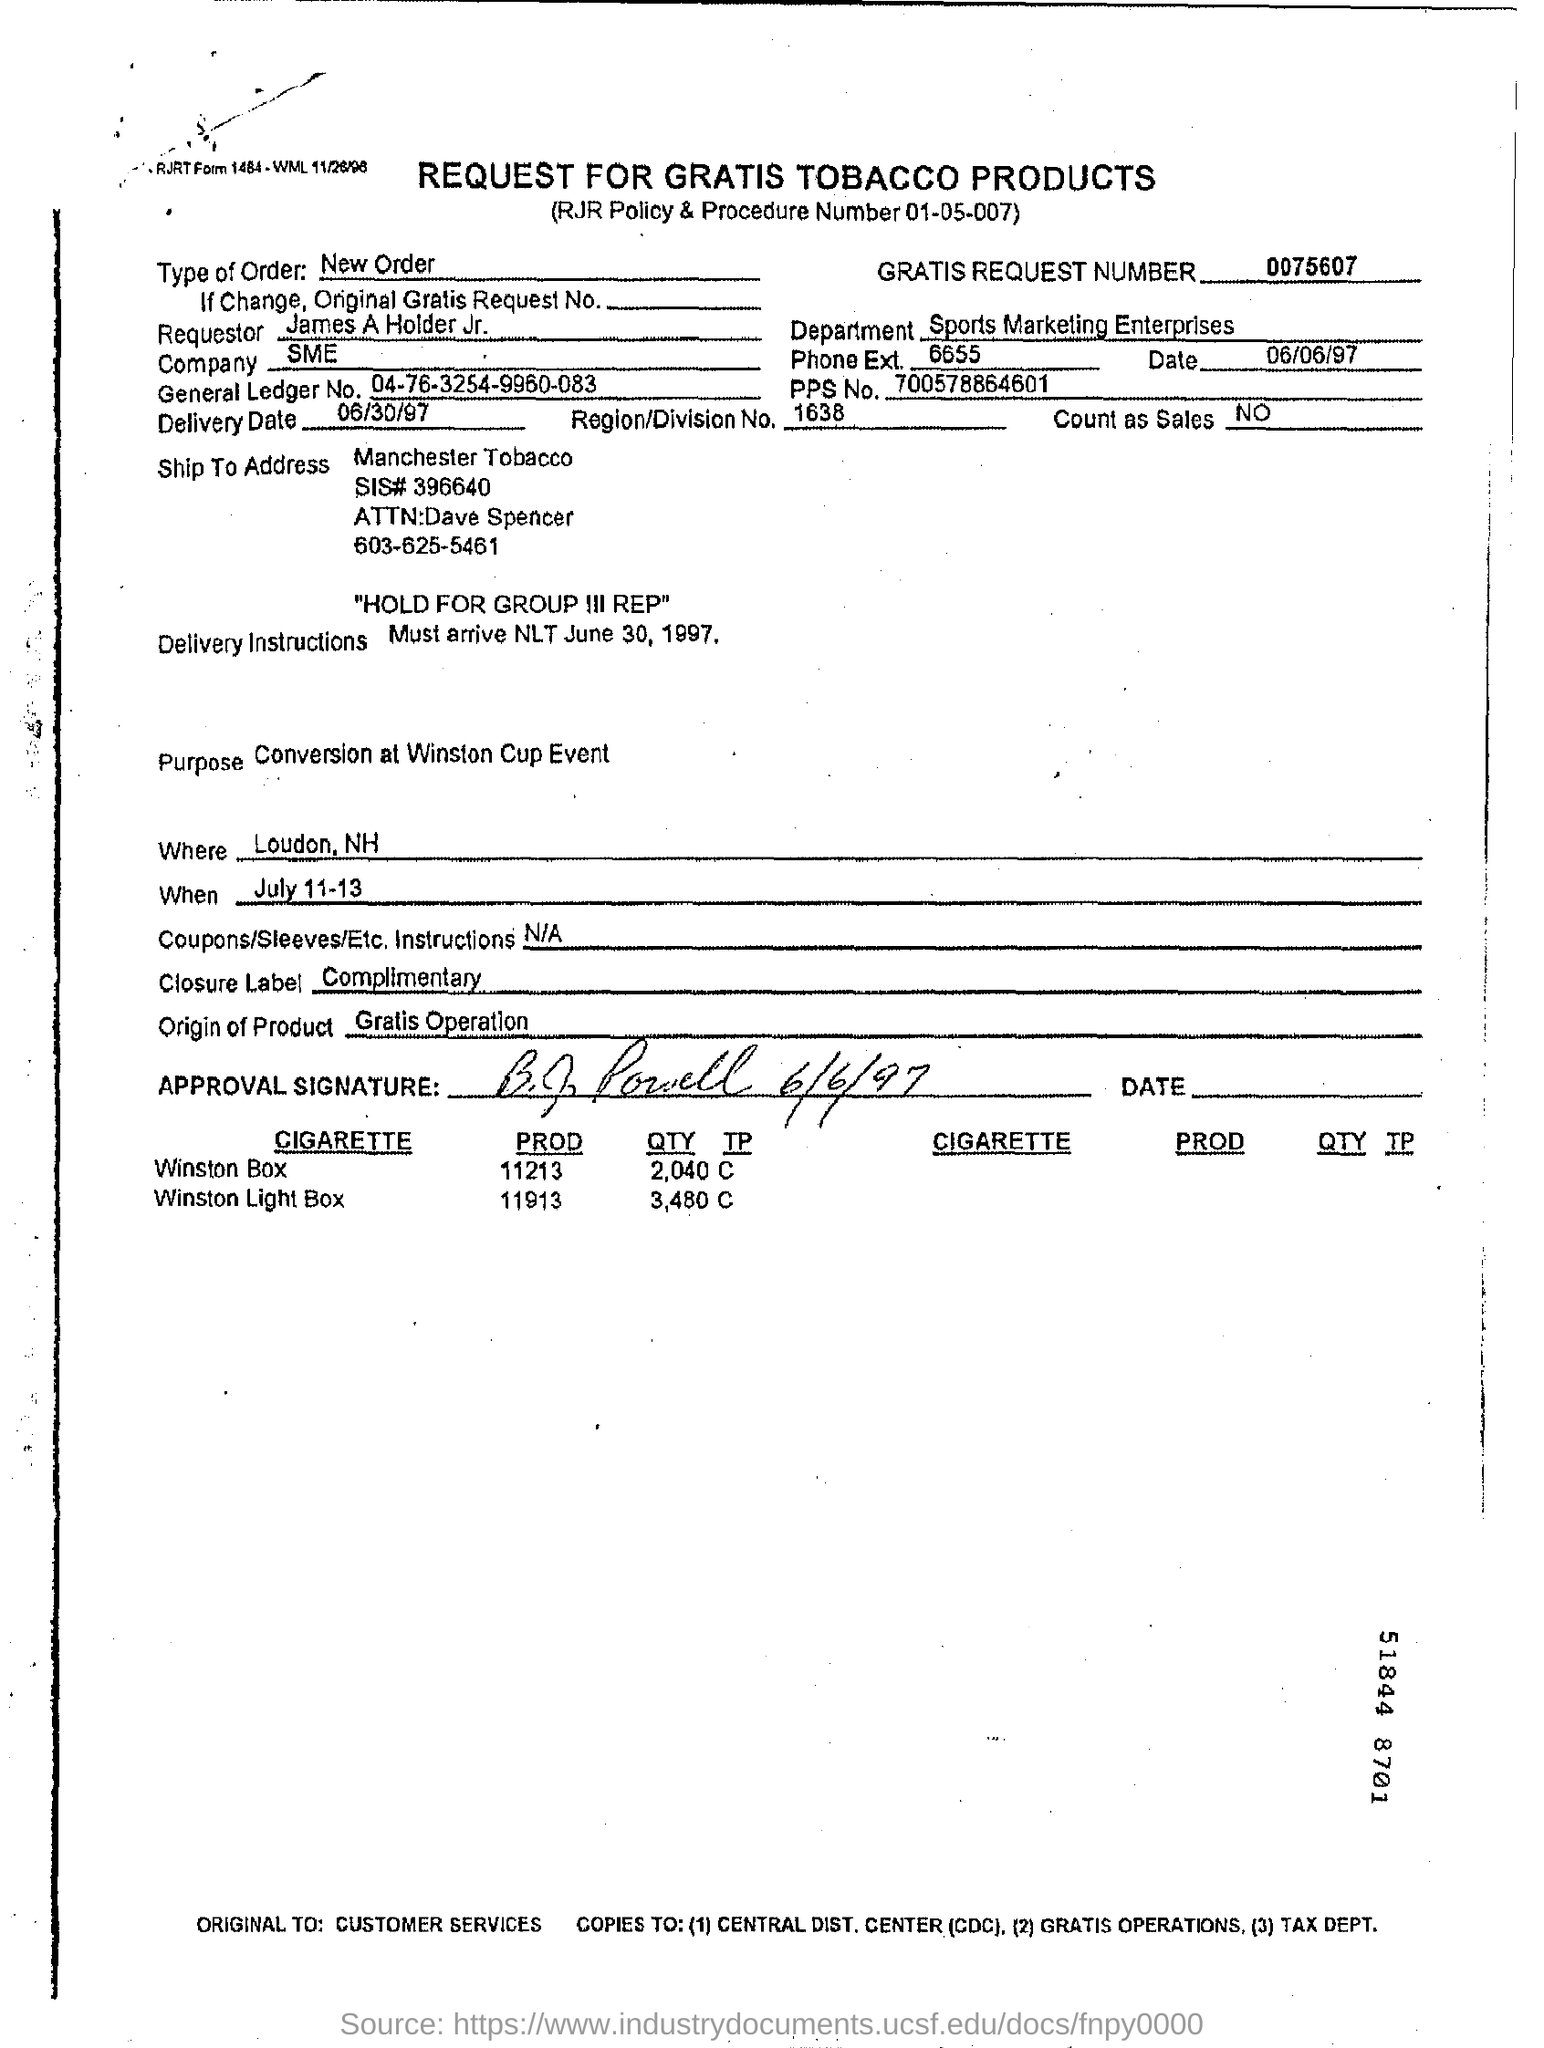Who is the Requestor?
Keep it short and to the point. James A Holder Jr. Which is the company?
Provide a short and direct response. SME. What is the Gratis Request Number?
Your answer should be very brief. 0075607. What is the Delivery Date?
Your answer should be compact. 06/30/97. What is the Region/Division No. ?
Your answer should be compact. 1638. What is the General Ledger No.?
Provide a short and direct response. 04-76-3254-9960-083. What is the Closure Label?
Ensure brevity in your answer.  Complimentary. What is the Type of Order?
Ensure brevity in your answer.  New Order. 